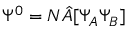<formula> <loc_0><loc_0><loc_500><loc_500>\Psi ^ { 0 } = N \hat { A } [ \Psi _ { A } \Psi _ { B } ]</formula> 